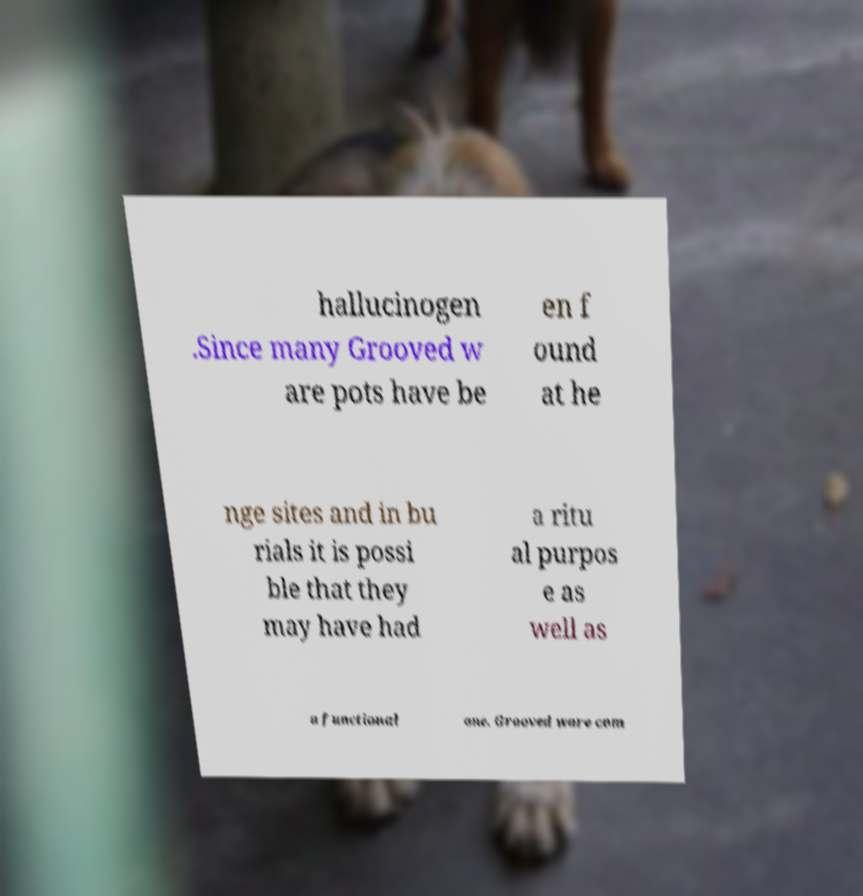I need the written content from this picture converted into text. Can you do that? hallucinogen .Since many Grooved w are pots have be en f ound at he nge sites and in bu rials it is possi ble that they may have had a ritu al purpos e as well as a functional one. Grooved ware com 